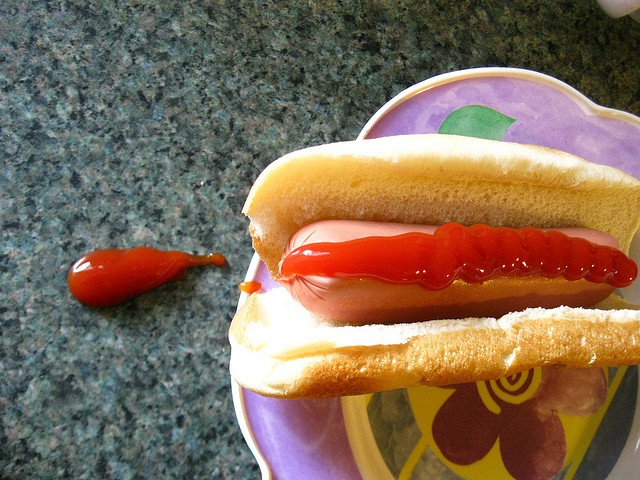Describe the objects in this image and their specific colors. I can see a hot dog in gray, ivory, red, maroon, and orange tones in this image. 